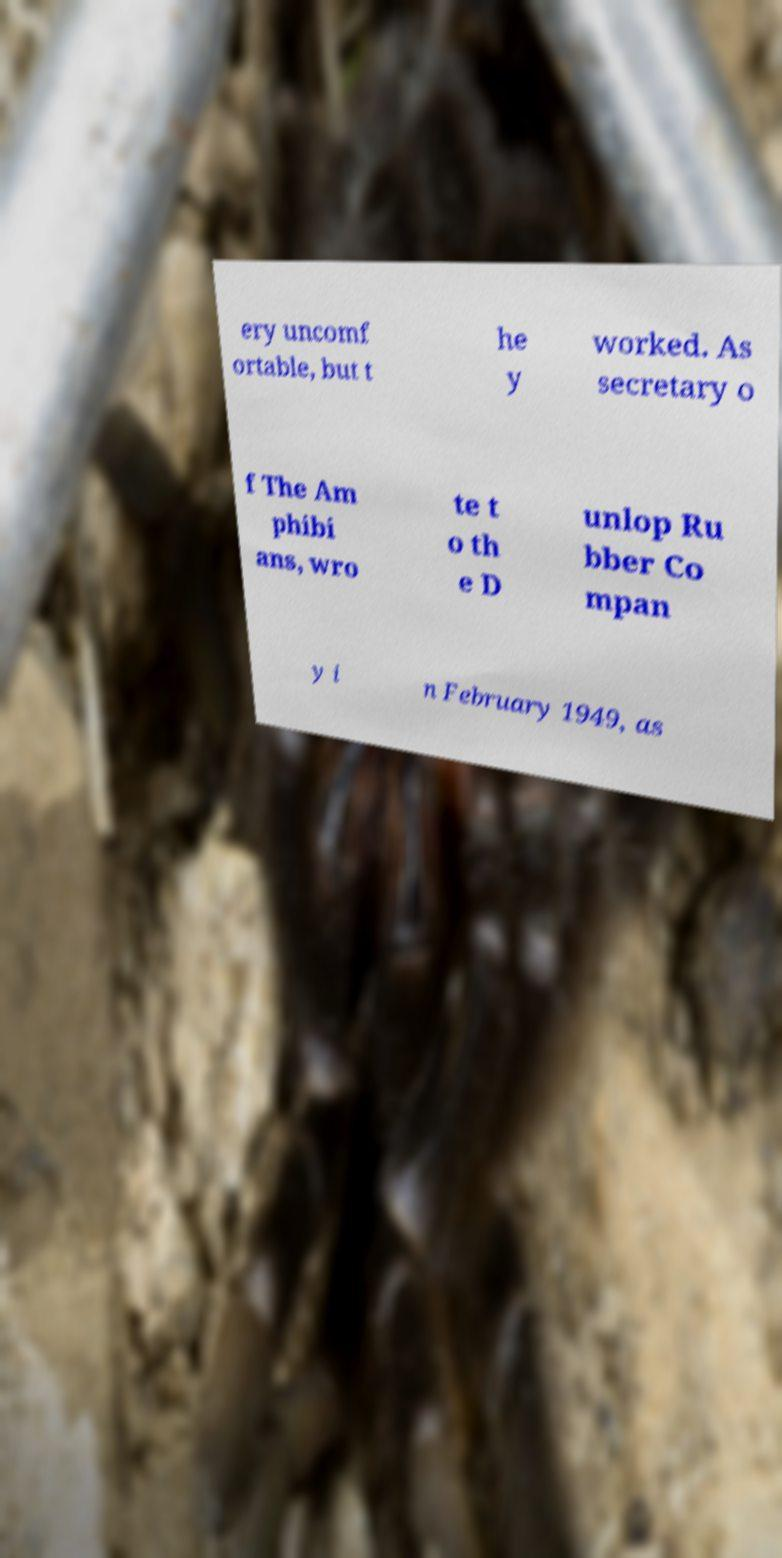What messages or text are displayed in this image? I need them in a readable, typed format. ery uncomf ortable, but t he y worked. As secretary o f The Am phibi ans, wro te t o th e D unlop Ru bber Co mpan y i n February 1949, as 